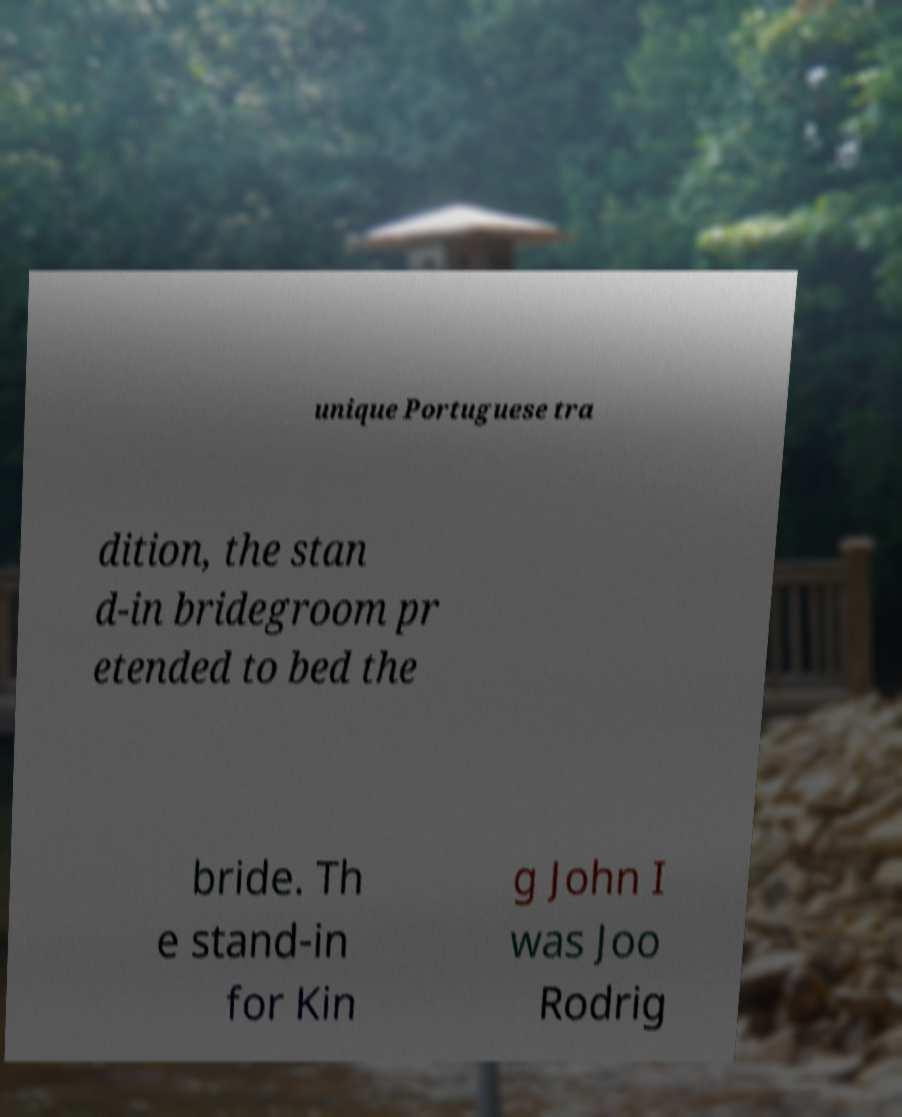What messages or text are displayed in this image? I need them in a readable, typed format. unique Portuguese tra dition, the stan d-in bridegroom pr etended to bed the bride. Th e stand-in for Kin g John I was Joo Rodrig 